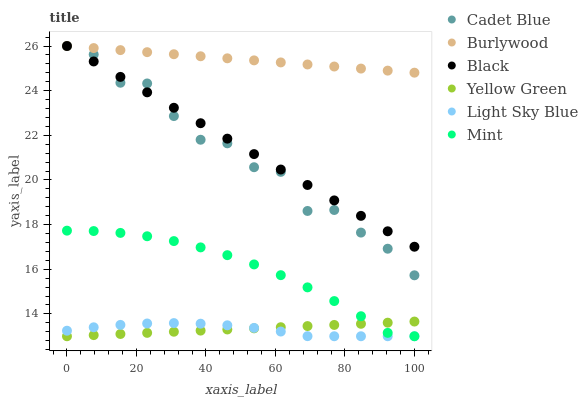Does Light Sky Blue have the minimum area under the curve?
Answer yes or no. Yes. Does Burlywood have the maximum area under the curve?
Answer yes or no. Yes. Does Yellow Green have the minimum area under the curve?
Answer yes or no. No. Does Yellow Green have the maximum area under the curve?
Answer yes or no. No. Is Black the smoothest?
Answer yes or no. Yes. Is Cadet Blue the roughest?
Answer yes or no. Yes. Is Yellow Green the smoothest?
Answer yes or no. No. Is Yellow Green the roughest?
Answer yes or no. No. Does Yellow Green have the lowest value?
Answer yes or no. Yes. Does Burlywood have the lowest value?
Answer yes or no. No. Does Black have the highest value?
Answer yes or no. Yes. Does Yellow Green have the highest value?
Answer yes or no. No. Is Yellow Green less than Cadet Blue?
Answer yes or no. Yes. Is Black greater than Yellow Green?
Answer yes or no. Yes. Does Yellow Green intersect Light Sky Blue?
Answer yes or no. Yes. Is Yellow Green less than Light Sky Blue?
Answer yes or no. No. Is Yellow Green greater than Light Sky Blue?
Answer yes or no. No. Does Yellow Green intersect Cadet Blue?
Answer yes or no. No. 